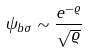<formula> <loc_0><loc_0><loc_500><loc_500>\psi _ { b \sigma } \sim \frac { e ^ { - \varrho } } { \sqrt { \varrho } }</formula> 